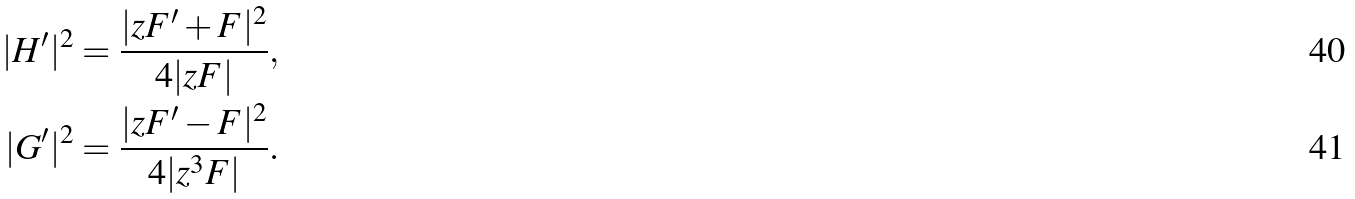Convert formula to latex. <formula><loc_0><loc_0><loc_500><loc_500>| H ^ { \prime } | ^ { 2 } = \frac { | z F ^ { \prime } + F | ^ { 2 } } { 4 | z F | } , \\ | G ^ { \prime } | ^ { 2 } = \frac { | z F ^ { \prime } - F | ^ { 2 } } { 4 | z ^ { 3 } F | } .</formula> 